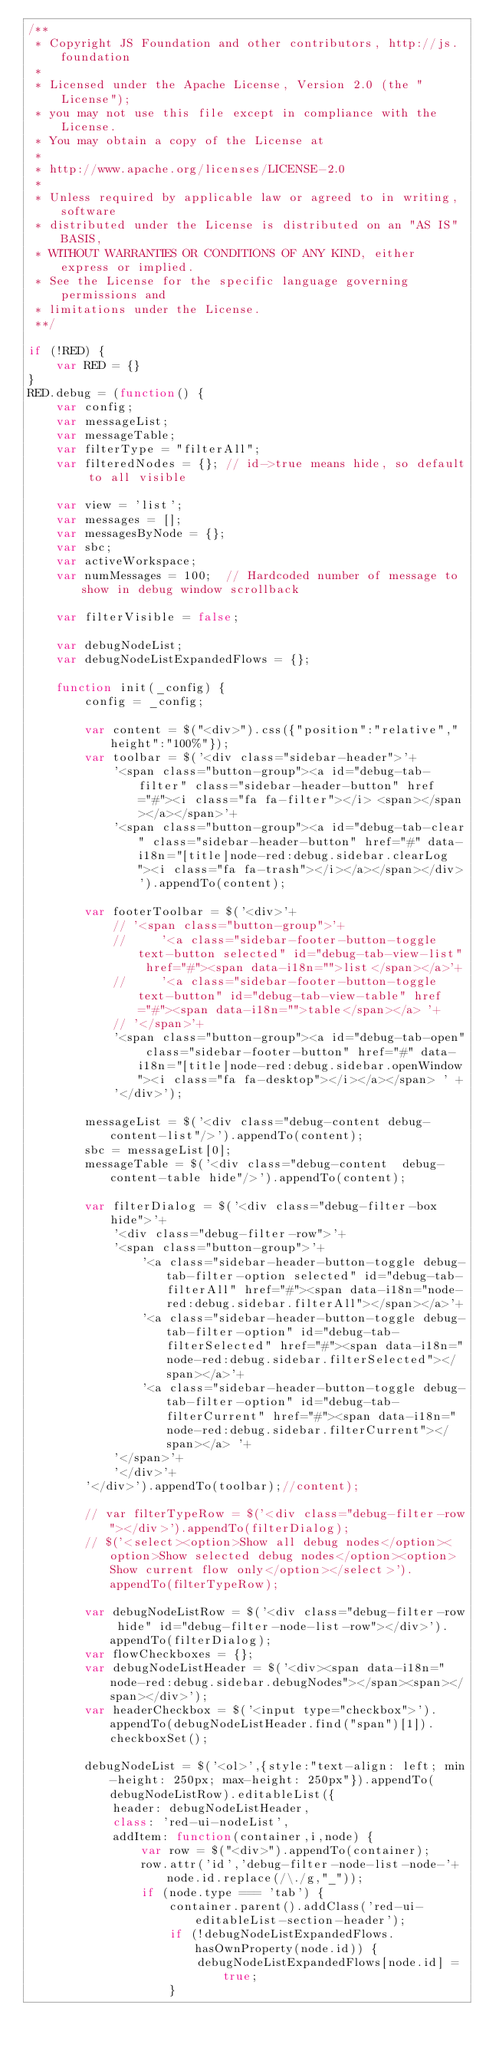<code> <loc_0><loc_0><loc_500><loc_500><_JavaScript_>/**
 * Copyright JS Foundation and other contributors, http://js.foundation
 *
 * Licensed under the Apache License, Version 2.0 (the "License");
 * you may not use this file except in compliance with the License.
 * You may obtain a copy of the License at
 *
 * http://www.apache.org/licenses/LICENSE-2.0
 *
 * Unless required by applicable law or agreed to in writing, software
 * distributed under the License is distributed on an "AS IS" BASIS,
 * WITHOUT WARRANTIES OR CONDITIONS OF ANY KIND, either express or implied.
 * See the License for the specific language governing permissions and
 * limitations under the License.
 **/

if (!RED) {
    var RED = {}
}
RED.debug = (function() {
    var config;
    var messageList;
    var messageTable;
    var filterType = "filterAll";
    var filteredNodes = {}; // id->true means hide, so default to all visible

    var view = 'list';
    var messages = [];
    var messagesByNode = {};
    var sbc;
    var activeWorkspace;
    var numMessages = 100;  // Hardcoded number of message to show in debug window scrollback

    var filterVisible = false;

    var debugNodeList;
    var debugNodeListExpandedFlows = {};

    function init(_config) {
        config = _config;

        var content = $("<div>").css({"position":"relative","height":"100%"});
        var toolbar = $('<div class="sidebar-header">'+
            '<span class="button-group"><a id="debug-tab-filter" class="sidebar-header-button" href="#"><i class="fa fa-filter"></i> <span></span></a></span>'+
            '<span class="button-group"><a id="debug-tab-clear" class="sidebar-header-button" href="#" data-i18n="[title]node-red:debug.sidebar.clearLog"><i class="fa fa-trash"></i></a></span></div>').appendTo(content);

        var footerToolbar = $('<div>'+
            // '<span class="button-group">'+
            //     '<a class="sidebar-footer-button-toggle text-button selected" id="debug-tab-view-list" href="#"><span data-i18n="">list</span></a>'+
            //     '<a class="sidebar-footer-button-toggle text-button" id="debug-tab-view-table" href="#"><span data-i18n="">table</span></a> '+
            // '</span>'+
            '<span class="button-group"><a id="debug-tab-open" class="sidebar-footer-button" href="#" data-i18n="[title]node-red:debug.sidebar.openWindow"><i class="fa fa-desktop"></i></a></span> ' +
            '</div>');

        messageList = $('<div class="debug-content debug-content-list"/>').appendTo(content);
        sbc = messageList[0];
        messageTable = $('<div class="debug-content  debug-content-table hide"/>').appendTo(content);

        var filterDialog = $('<div class="debug-filter-box hide">'+
            '<div class="debug-filter-row">'+
            '<span class="button-group">'+
                '<a class="sidebar-header-button-toggle debug-tab-filter-option selected" id="debug-tab-filterAll" href="#"><span data-i18n="node-red:debug.sidebar.filterAll"></span></a>'+
                '<a class="sidebar-header-button-toggle debug-tab-filter-option" id="debug-tab-filterSelected" href="#"><span data-i18n="node-red:debug.sidebar.filterSelected"></span></a>'+
                '<a class="sidebar-header-button-toggle debug-tab-filter-option" id="debug-tab-filterCurrent" href="#"><span data-i18n="node-red:debug.sidebar.filterCurrent"></span></a> '+
            '</span>'+
            '</div>'+
        '</div>').appendTo(toolbar);//content);

        // var filterTypeRow = $('<div class="debug-filter-row"></div>').appendTo(filterDialog);
        // $('<select><option>Show all debug nodes</option><option>Show selected debug nodes</option><option>Show current flow only</option></select>').appendTo(filterTypeRow);

        var debugNodeListRow = $('<div class="debug-filter-row hide" id="debug-filter-node-list-row"></div>').appendTo(filterDialog);
        var flowCheckboxes = {};
        var debugNodeListHeader = $('<div><span data-i18n="node-red:debug.sidebar.debugNodes"></span><span></span></div>');
        var headerCheckbox = $('<input type="checkbox">').appendTo(debugNodeListHeader.find("span")[1]).checkboxSet();

        debugNodeList = $('<ol>',{style:"text-align: left; min-height: 250px; max-height: 250px"}).appendTo(debugNodeListRow).editableList({
            header: debugNodeListHeader,
            class: 'red-ui-nodeList',
            addItem: function(container,i,node) {
                var row = $("<div>").appendTo(container);
                row.attr('id','debug-filter-node-list-node-'+node.id.replace(/\./g,"_"));
                if (node.type === 'tab') {
                    container.parent().addClass('red-ui-editableList-section-header');
                    if (!debugNodeListExpandedFlows.hasOwnProperty(node.id)) {
                        debugNodeListExpandedFlows[node.id] = true;
                    }</code> 